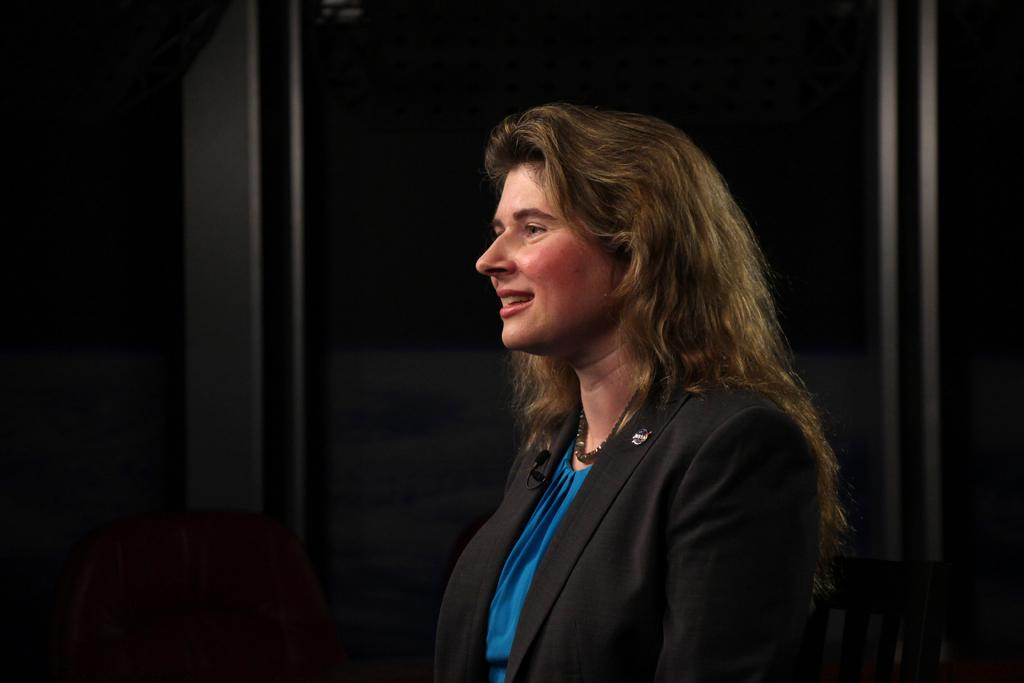Who is the main subject in the image? There is a woman in the front of the image. What objects are in the front of the image alongside the woman? There are chairs in the front of the image. How would you describe the overall lighting in the image? The background of the image is dark. What type of bait is the woman using in the image? There is no bait present in the image; it features a woman and chairs in a dark setting. 